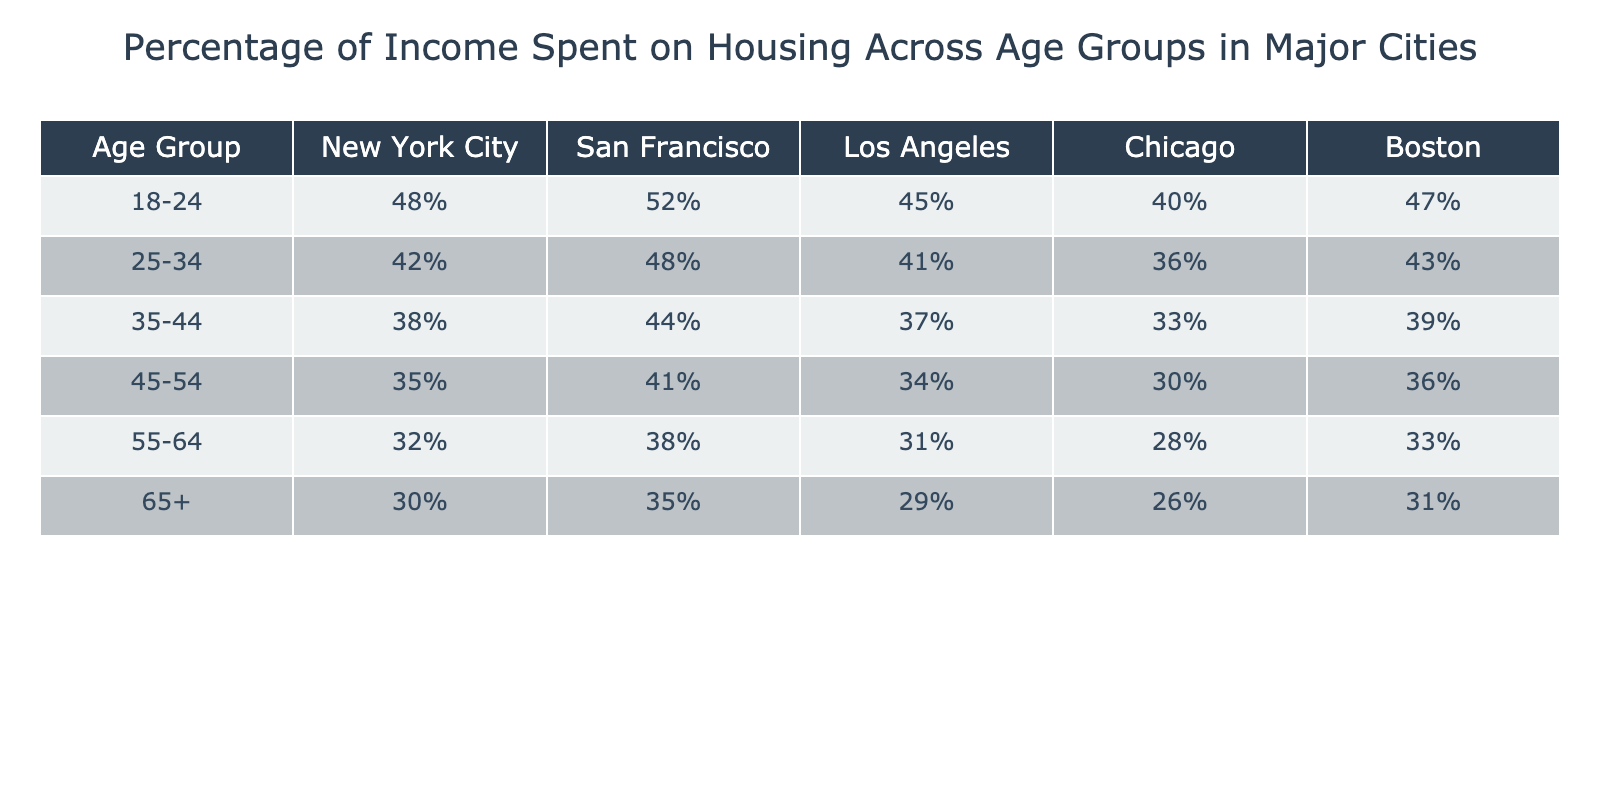What is the percentage of income spent on housing by the 25-34 age group in San Francisco? According to the table, the percentage of income spent on housing for the 25-34 age group in San Francisco is listed as 48%.
Answer: 48% Which age group spends the least percentage of income on housing in Chicago? Looking at the table for Chicago, the age group 65+ spends the least percentage of income on housing, which is 26%.
Answer: 26% What is the difference in the percentage of income spent on housing between the 35-44 age group in New York City and Los Angeles? The percentage for New York City (38%) minus the percentage for Los Angeles (37%) is 1%. Thus, there is a 1% difference.
Answer: 1% Is it true that the 45-54 age group spends more on housing in Boston than in New York City? Checking the values, the 45-54 age group spends 36% in Boston and 35% in New York City. Since 36% is greater than 35%, the statement is true.
Answer: Yes What is the average percentage of income spent on housing for the 18-24 age group across all cities listed? Summing the percentages for the 18-24 age group: 48% + 52% + 45% + 40% + 47% = 232%. There are 5 cities, so the average is 232% / 5 = 46.4%.
Answer: 46.4% Which city has the highest percentage of income spent on housing by the 55-64 age group? By looking at the table, San Francisco has the highest percentage at 38% for the 55-64 age group.
Answer: San Francisco What percentage of income is spent on housing by the 65+ age group in Boston compared to New York City? The percentage in Boston is 31% and in New York City, it is 30%. The difference is 31% - 30% = 1%. Thus, Boston has 1% more.
Answer: 1% Which age group has the highest housing expense in Los Angeles? In the table, the 18-24 age group has the highest percentage in Los Angeles at 45%.
Answer: 45% What is the total percentage spent on housing for the 25-34 and 35-44 age groups combined in Chicago? The percentages are 36% (25-34) and 33% (35-44). Adding them gives 36% + 33% = 69%.
Answer: 69% In which city do individuals aged 55-64 spend the least percentage of their income on housing? Looking at the table, the least percentage spent is in Chicago, at 28%.
Answer: Chicago Is the percentage for the 45-54 age group in San Francisco greater than that in Los Angeles? The data shows 41% for San Francisco and 34% for Los Angeles. Since 41% is greater, the statement is true.
Answer: Yes 